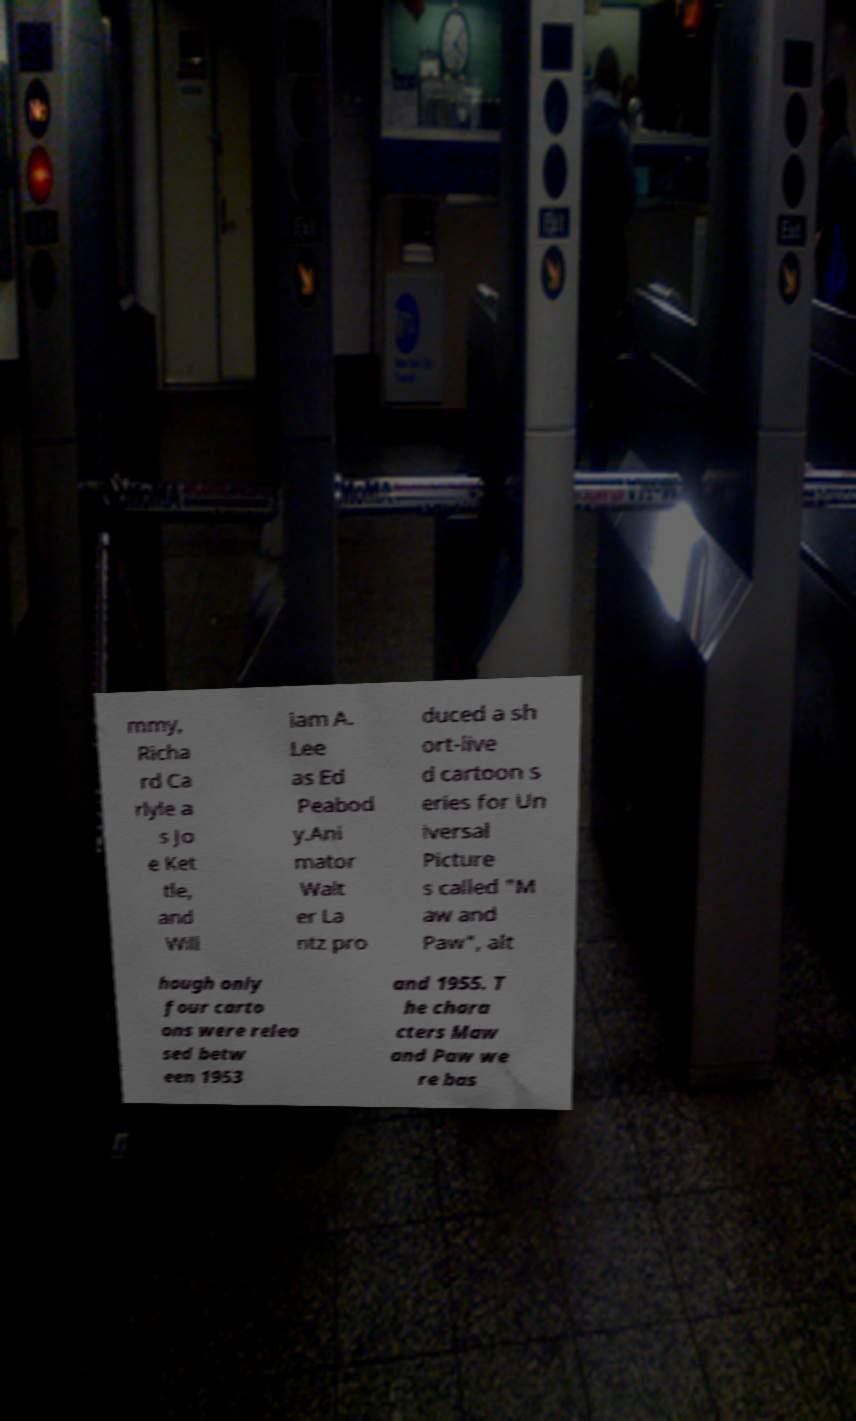Please read and relay the text visible in this image. What does it say? mmy, Richa rd Ca rlyle a s Jo e Ket tle, and Will iam A. Lee as Ed Peabod y.Ani mator Walt er La ntz pro duced a sh ort-live d cartoon s eries for Un iversal Picture s called "M aw and Paw", alt hough only four carto ons were relea sed betw een 1953 and 1955. T he chara cters Maw and Paw we re bas 